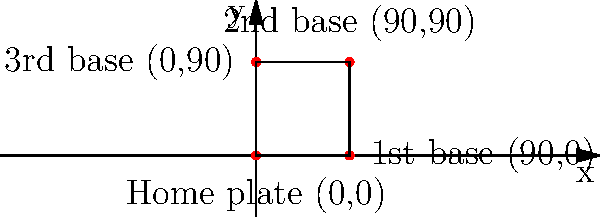As a local sports reporter covering the Pine Bluff Zebras baseball team, you're tasked with explaining the layout of a baseball diamond using a coordinate system. The coach has provided you with the following information: home plate is at (0,0), first base is at (90,0), second base is at (90,90), and third base is at (0,90). What is the total distance, in feet, that a player would run if they hit a home run and touched all four bases in order? Let's break this down step-by-step:

1) First, we need to calculate the distance between each base:

   a) From home to first: 
      Distance = $\sqrt{(90-0)^2 + (0-0)^2} = 90$ feet

   b) From first to second:
      Distance = $\sqrt{(90-90)^2 + (90-0)^2} = 90$ feet

   c) From second to third:
      Distance = $\sqrt{(0-90)^2 + (90-90)^2} = 90$ feet

   d) From third to home:
      Distance = $\sqrt{(0-0)^2 + (0-90)^2} = 90$ feet

2) Now, we sum up all these distances:

   Total distance = 90 + 90 + 90 + 90 = 360 feet

Therefore, a player running a home run would cover a total distance of 360 feet.
Answer: 360 feet 